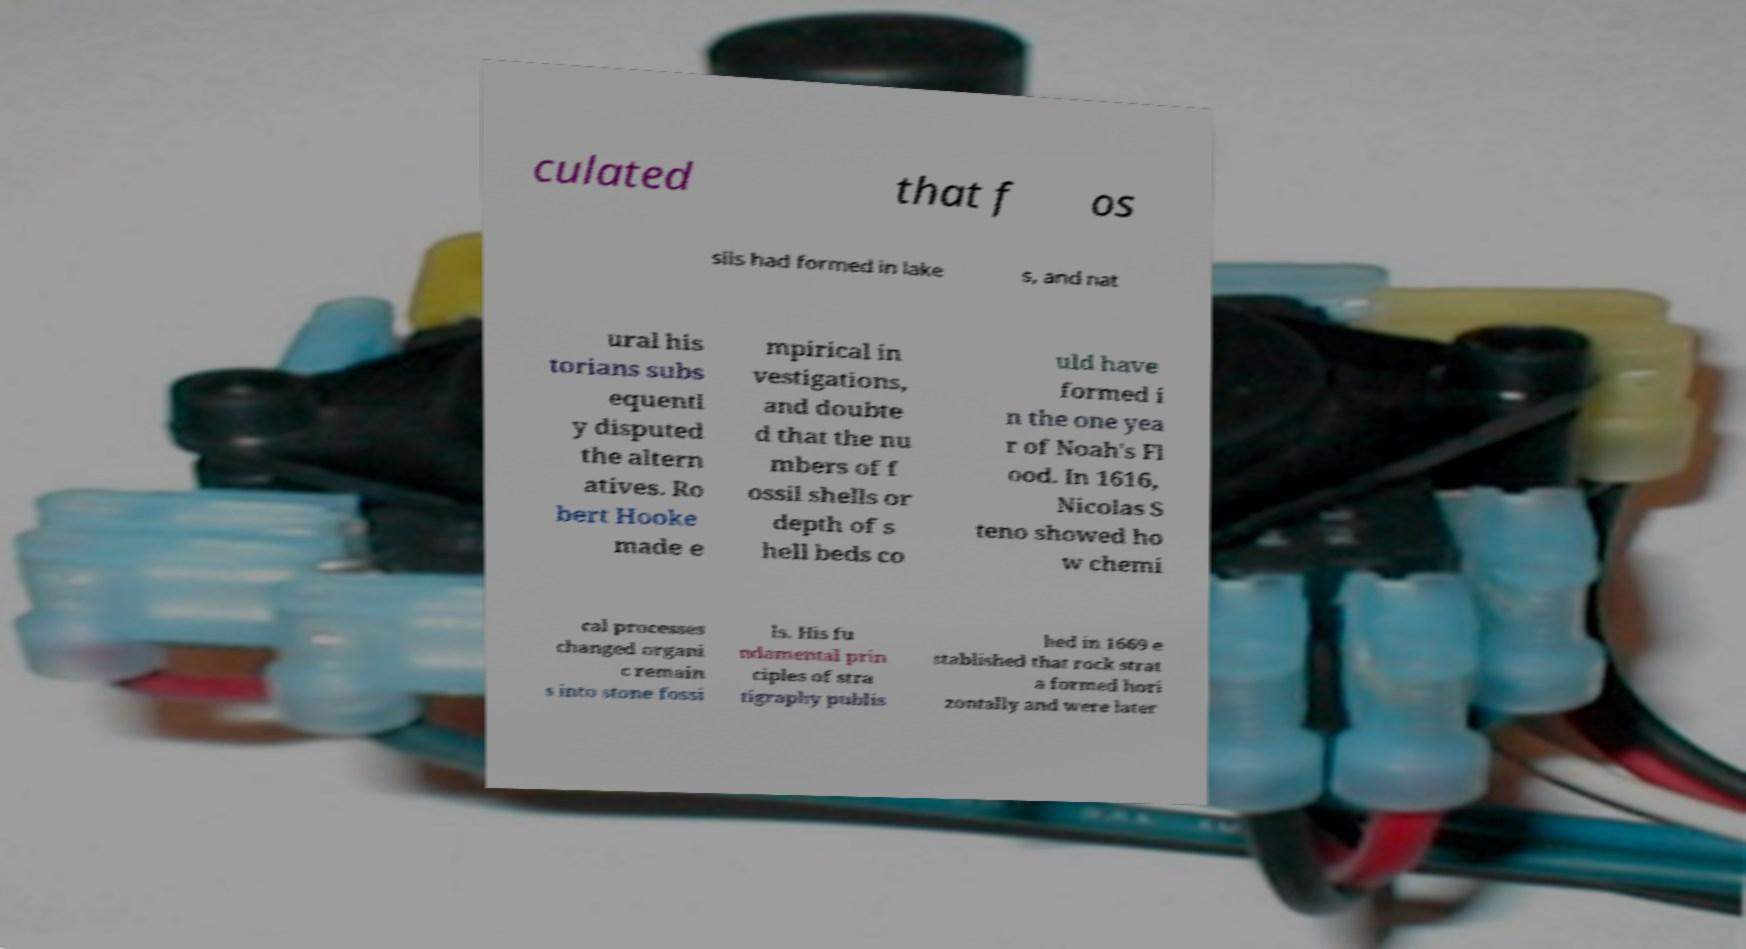Can you read and provide the text displayed in the image?This photo seems to have some interesting text. Can you extract and type it out for me? culated that f os sils had formed in lake s, and nat ural his torians subs equentl y disputed the altern atives. Ro bert Hooke made e mpirical in vestigations, and doubte d that the nu mbers of f ossil shells or depth of s hell beds co uld have formed i n the one yea r of Noah's Fl ood. In 1616, Nicolas S teno showed ho w chemi cal processes changed organi c remain s into stone fossi ls. His fu ndamental prin ciples of stra tigraphy publis hed in 1669 e stablished that rock strat a formed hori zontally and were later 